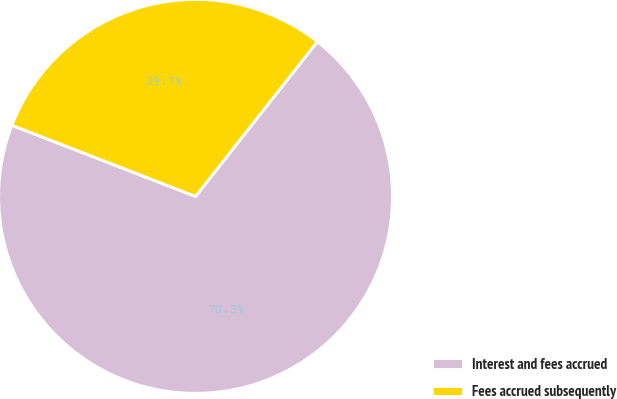<chart> <loc_0><loc_0><loc_500><loc_500><pie_chart><fcel>Interest and fees accrued<fcel>Fees accrued subsequently<nl><fcel>70.27%<fcel>29.73%<nl></chart> 